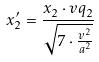<formula> <loc_0><loc_0><loc_500><loc_500>x _ { 2 } ^ { \prime } = \frac { x _ { 2 } \cdot v q _ { 2 } } { \sqrt { 7 \cdot \frac { v ^ { 2 } } { a ^ { 2 } } } }</formula> 